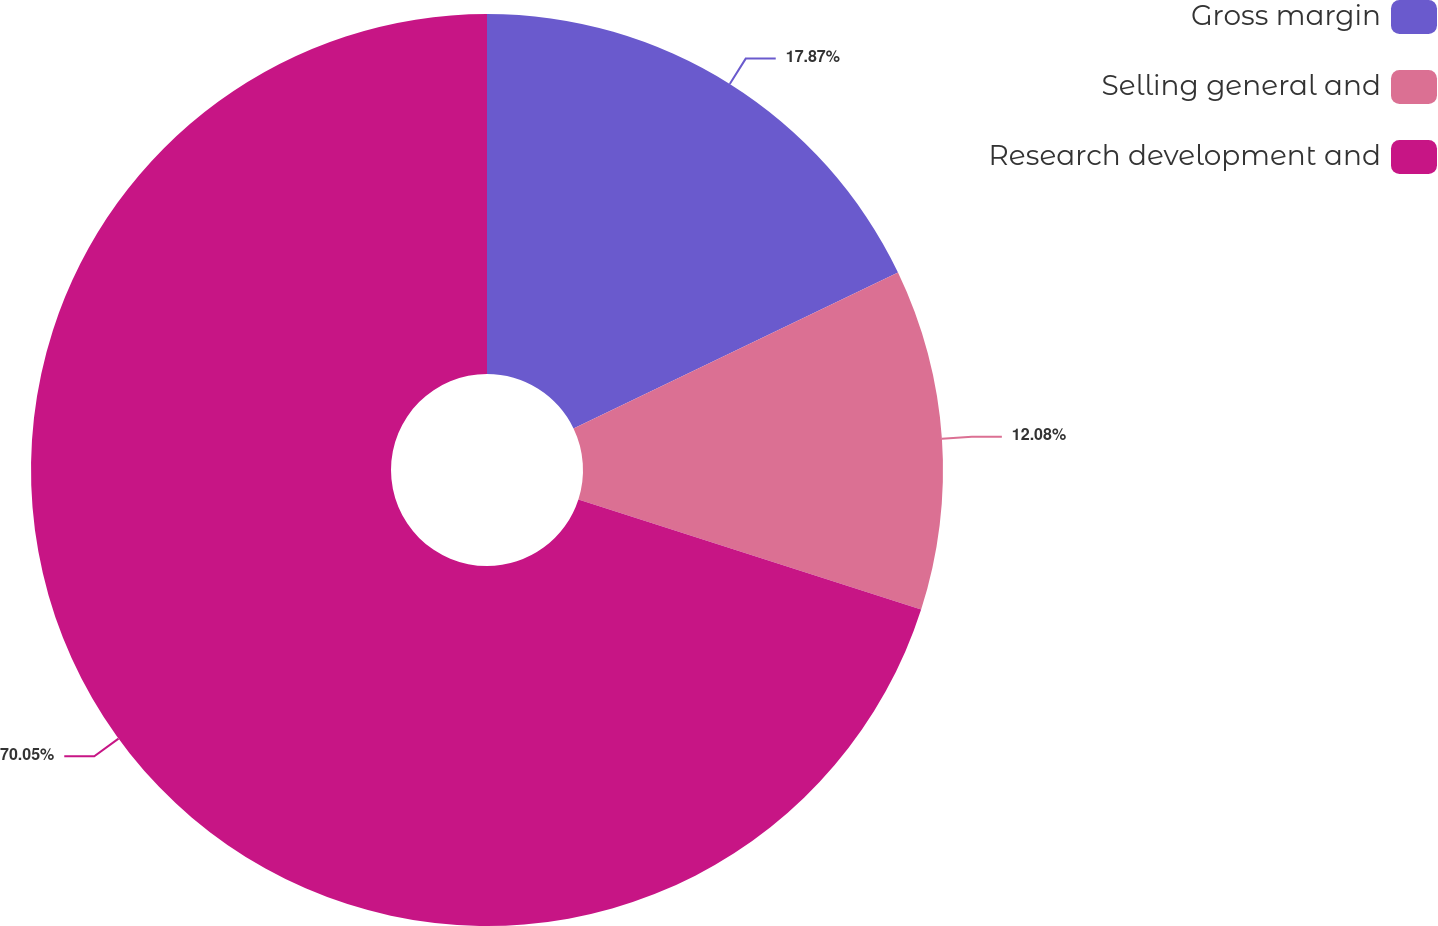<chart> <loc_0><loc_0><loc_500><loc_500><pie_chart><fcel>Gross margin<fcel>Selling general and<fcel>Research development and<nl><fcel>17.87%<fcel>12.08%<fcel>70.05%<nl></chart> 